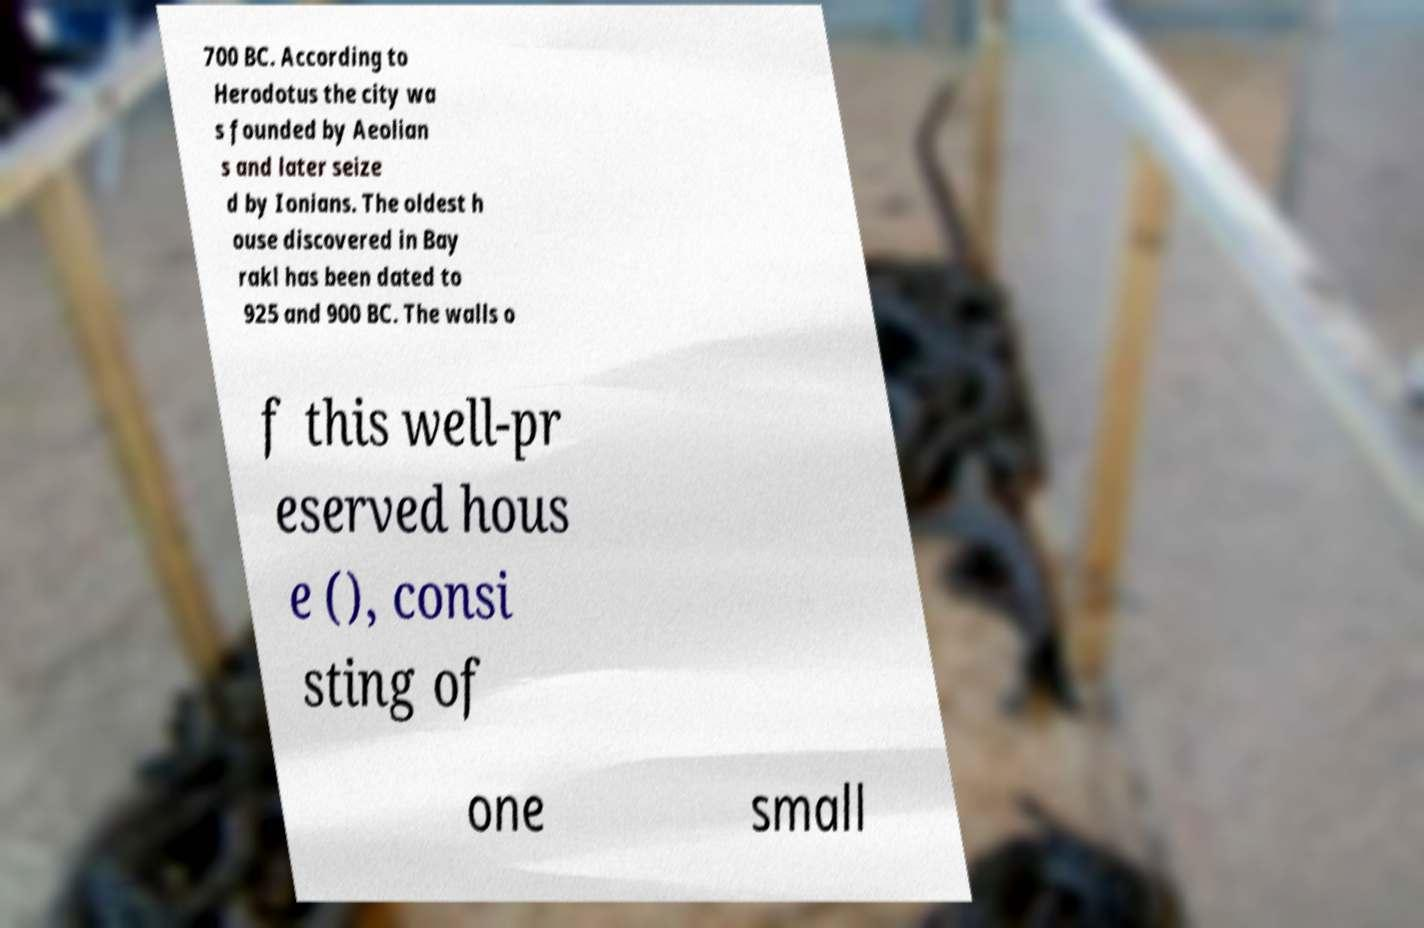Please read and relay the text visible in this image. What does it say? 700 BC. According to Herodotus the city wa s founded by Aeolian s and later seize d by Ionians. The oldest h ouse discovered in Bay rakl has been dated to 925 and 900 BC. The walls o f this well-pr eserved hous e (), consi sting of one small 